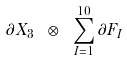<formula> <loc_0><loc_0><loc_500><loc_500>\partial X _ { 3 } \ \otimes \ \sum _ { I = 1 } ^ { 1 0 } \partial F _ { I }</formula> 